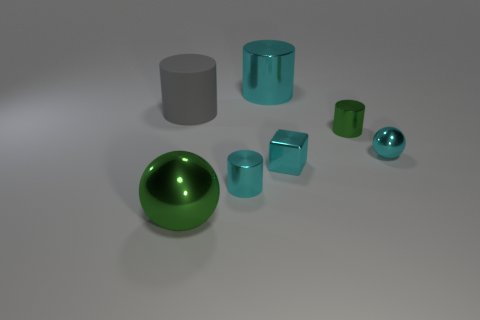There is a large shiny thing in front of the rubber cylinder; are there any big matte objects in front of it?
Your answer should be compact. No. What number of things are green objects that are on the left side of the cyan block or big gray matte cylinders?
Give a very brief answer. 2. Are there any other things that are the same size as the cyan block?
Offer a very short reply. Yes. What material is the cylinder that is in front of the green metallic thing that is behind the big sphere?
Your answer should be very brief. Metal. Are there an equal number of large metal things left of the big gray rubber object and gray matte objects that are in front of the small green shiny cylinder?
Give a very brief answer. Yes. How many things are either large shiny things behind the big gray rubber cylinder or metal things in front of the large gray matte thing?
Provide a short and direct response. 6. What is the thing that is on the left side of the tiny green cylinder and right of the big cyan metallic thing made of?
Provide a short and direct response. Metal. What is the size of the shiny ball in front of the sphere that is behind the tiny shiny cube right of the large gray object?
Ensure brevity in your answer.  Large. Are there more big gray cylinders than spheres?
Your answer should be very brief. No. Does the tiny thing that is right of the small green thing have the same material as the big cyan cylinder?
Make the answer very short. Yes. 